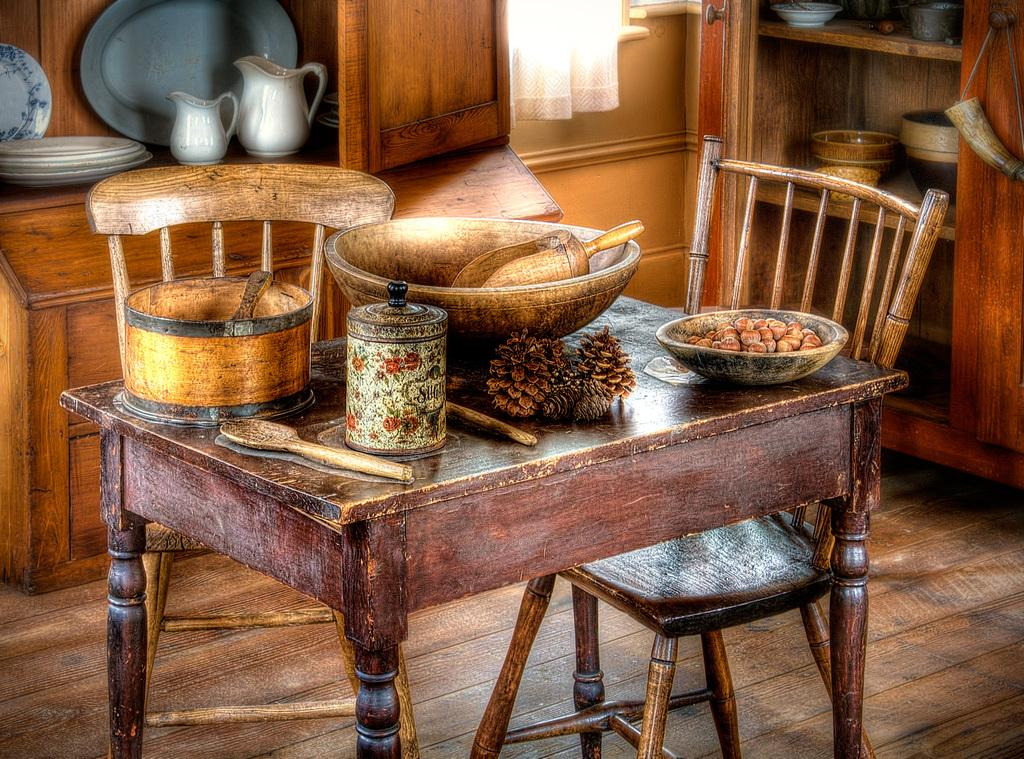What types of objects can be seen in the image? There are food items and containers in the image. Where are the food items and containers located? They are on a table in the image. What is the color of the food items and containers in the image? Everything in the image is brown in color. Can you see anyone jumping on the sheet in the image? There is no sheet or anyone jumping in the image; the image only contains food items and containers on a table. 